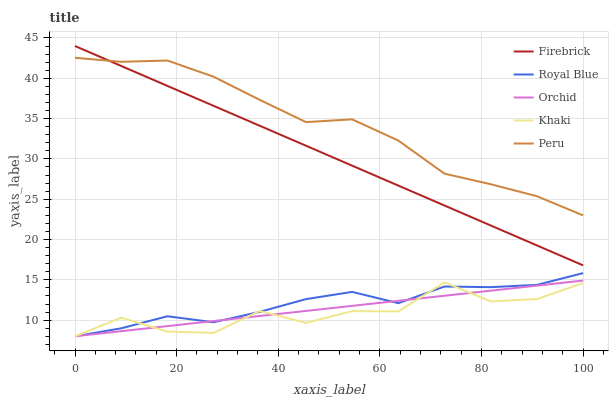Does Khaki have the minimum area under the curve?
Answer yes or no. Yes. Does Peru have the maximum area under the curve?
Answer yes or no. Yes. Does Firebrick have the minimum area under the curve?
Answer yes or no. No. Does Firebrick have the maximum area under the curve?
Answer yes or no. No. Is Orchid the smoothest?
Answer yes or no. Yes. Is Khaki the roughest?
Answer yes or no. Yes. Is Firebrick the smoothest?
Answer yes or no. No. Is Firebrick the roughest?
Answer yes or no. No. Does Firebrick have the lowest value?
Answer yes or no. No. Does Firebrick have the highest value?
Answer yes or no. Yes. Does Khaki have the highest value?
Answer yes or no. No. Is Royal Blue less than Peru?
Answer yes or no. Yes. Is Firebrick greater than Royal Blue?
Answer yes or no. Yes. Does Royal Blue intersect Peru?
Answer yes or no. No. 